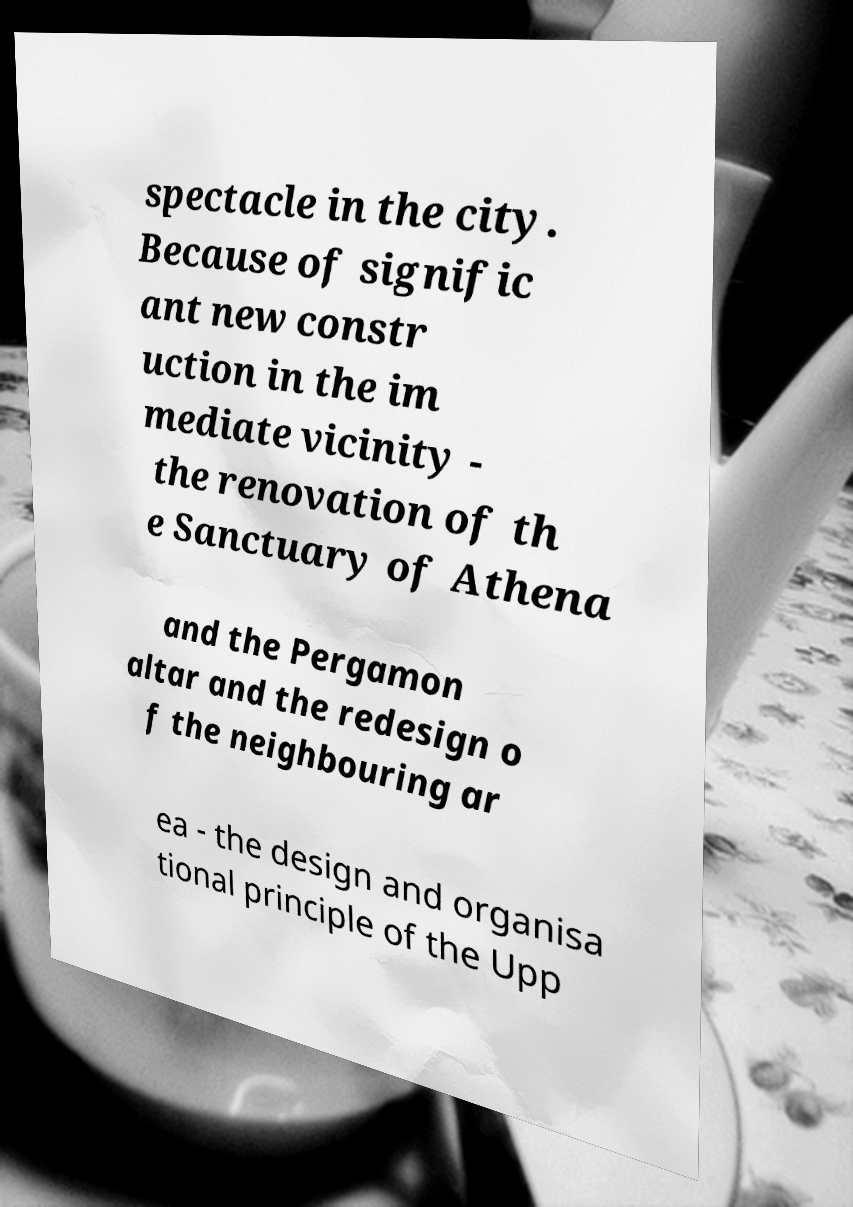What messages or text are displayed in this image? I need them in a readable, typed format. spectacle in the city. Because of signific ant new constr uction in the im mediate vicinity - the renovation of th e Sanctuary of Athena and the Pergamon altar and the redesign o f the neighbouring ar ea - the design and organisa tional principle of the Upp 